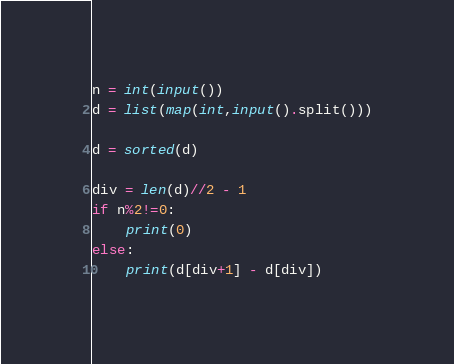Convert code to text. <code><loc_0><loc_0><loc_500><loc_500><_Python_>n = int(input())
d = list(map(int,input().split()))

d = sorted(d)

div = len(d)//2 - 1
if n%2!=0:
	print(0)
else:
	print(d[div+1] - d[div])</code> 